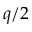<formula> <loc_0><loc_0><loc_500><loc_500>q / 2</formula> 